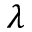<formula> <loc_0><loc_0><loc_500><loc_500>\lambda</formula> 